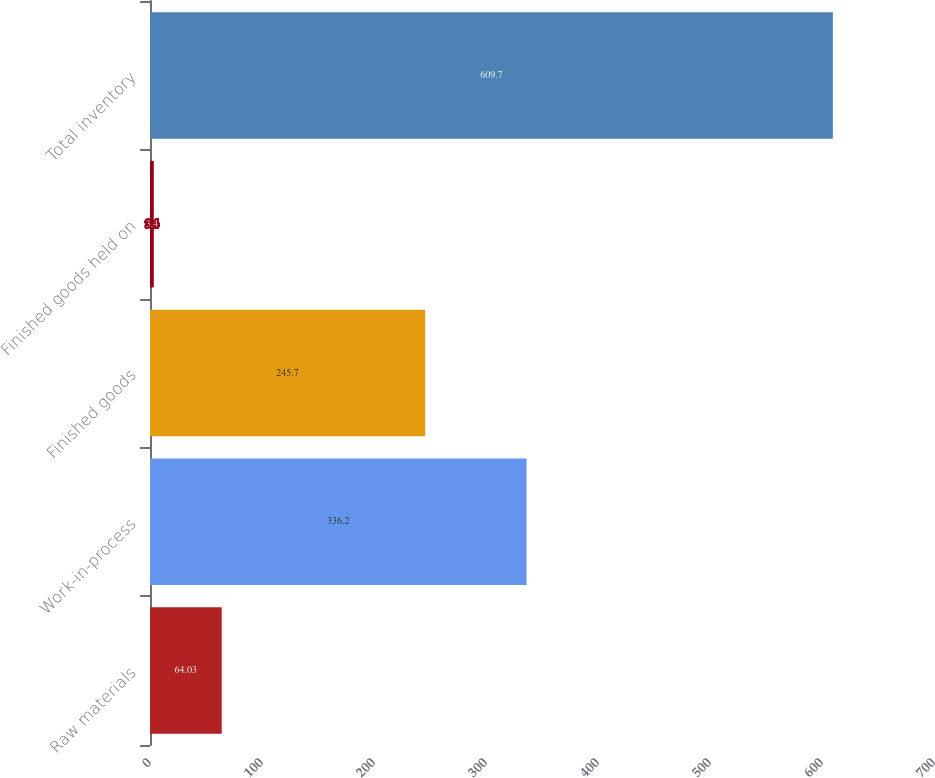<chart> <loc_0><loc_0><loc_500><loc_500><bar_chart><fcel>Raw materials<fcel>Work-in-process<fcel>Finished goods<fcel>Finished goods held on<fcel>Total inventory<nl><fcel>64.03<fcel>336.2<fcel>245.7<fcel>3.4<fcel>609.7<nl></chart> 